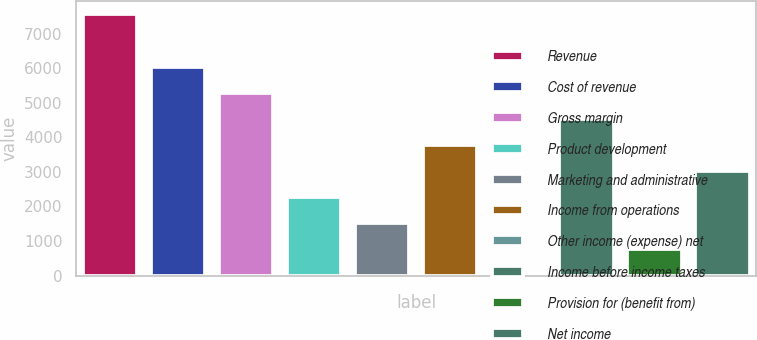<chart> <loc_0><loc_0><loc_500><loc_500><bar_chart><fcel>Revenue<fcel>Cost of revenue<fcel>Gross margin<fcel>Product development<fcel>Marketing and administrative<fcel>Income from operations<fcel>Other income (expense) net<fcel>Income before income taxes<fcel>Provision for (benefit from)<fcel>Net income<nl><fcel>7553<fcel>6044.4<fcel>5290.1<fcel>2272.9<fcel>1518.6<fcel>3781.5<fcel>10<fcel>4535.8<fcel>764.3<fcel>3027.2<nl></chart> 